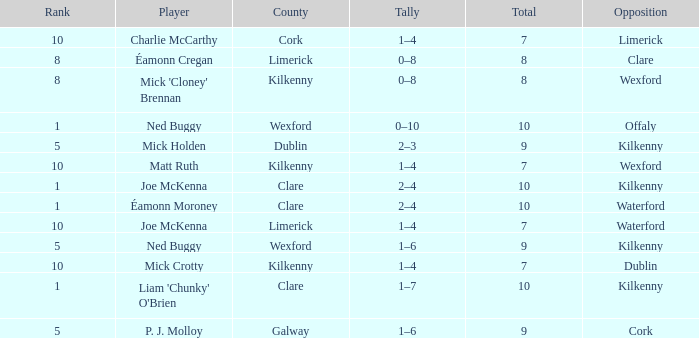What is galway county's total? 9.0. 